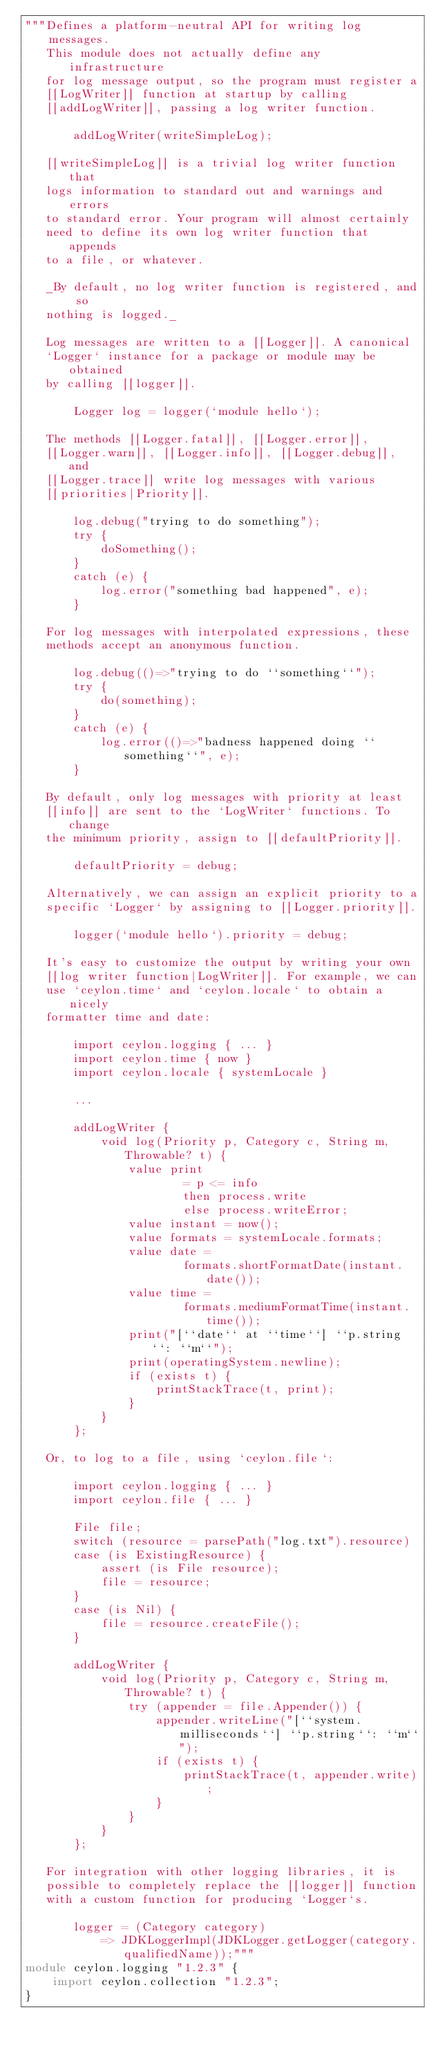<code> <loc_0><loc_0><loc_500><loc_500><_Ceylon_>"""Defines a platform-neutral API for writing log messages.
   This module does not actually define any infrastructure
   for log message output, so the program must register a
   [[LogWriter]] function at startup by calling 
   [[addLogWriter]], passing a log writer function.
   
       addLogWriter(writeSimpleLog);
   
   [[writeSimpleLog]] is a trivial log writer function that
   logs information to standard out and warnings and errors 
   to standard error. Your program will almost certainly 
   need to define its own log writer function that appends
   to a file, or whatever. 
   
   _By default, no log writer function is registered, and so
   nothing is logged._
   
   Log messages are written to a [[Logger]]. A canonical 
   `Logger` instance for a package or module may be obtained 
   by calling [[logger]].
   
       Logger log = logger(`module hello`);
   
   The methods [[Logger.fatal]], [[Logger.error]], 
   [[Logger.warn]], [[Logger.info]], [[Logger.debug]], and 
   [[Logger.trace]] write log messages with various
   [[priorities|Priority]].
   
       log.debug("trying to do something");
       try {
           doSomething();
       }
       catch (e) {
           log.error("something bad happened", e);
       }
   
   For log messages with interpolated expressions, these
   methods accept an anonymous function.
     
       log.debug(()=>"trying to do ``something``");
       try {
           do(something);
       }
       catch (e) {
           log.error(()=>"badness happened doing ``something``", e);
       }
    
   By default, only log messages with priority at least 
   [[info]] are sent to the `LogWriter` functions. To change
   the minimum priority, assign to [[defaultPriority]].
   
       defaultPriority = debug;
   
   Alternatively, we can assign an explicit priority to a
   specific `Logger` by assigning to [[Logger.priority]].
   
       logger(`module hello`).priority = debug;
   
   It's easy to customize the output by writing your own
   [[log writer function|LogWriter]]. For example, we can
   use `ceylon.time` and `ceylon.locale` to obtain a nicely
   formatter time and date:
   
       import ceylon.logging { ... }
       import ceylon.time { now }
       import ceylon.locale { systemLocale }
       
       ...
       
       addLogWriter {
           void log(Priority p, Category c, String m, Throwable? t) {
               value print 
                       = p <= info 
                       then process.write
                       else process.writeError;
               value instant = now();
               value formats = systemLocale.formats;
               value date = 
                       formats.shortFormatDate(instant.date());
               value time = 
                       formats.mediumFormatTime(instant.time());
               print("[``date`` at ``time``] ``p.string``: ``m``");
               print(operatingSystem.newline);
               if (exists t) {
                   printStackTrace(t, print);
               }
           }
       };
   
   Or, to log to a file, using `ceylon.file`:
   
       import ceylon.logging { ... }
       import ceylon.file { ... }

       File file;
       switch (resource = parsePath("log.txt").resource)
       case (is ExistingResource) {
           assert (is File resource);
           file = resource;
       }
       case (is Nil) {
           file = resource.createFile();
       }
       
       addLogWriter {
           void log(Priority p, Category c, String m, Throwable? t) {
               try (appender = file.Appender()) {
                   appender.writeLine("[``system.milliseconds``] ``p.string``: ``m``");
                   if (exists t) {
                       printStackTrace(t, appender.write);
                   }
               }
           }
       };
   
   For integration with other logging libraries, it is
   possible to completely replace the [[logger]] function
   with a custom function for producing `Logger`s.
   
       logger = (Category category)
           => JDKLoggerImpl(JDKLogger.getLogger(category.qualifiedName));"""
module ceylon.logging "1.2.3" {
    import ceylon.collection "1.2.3";
}
</code> 